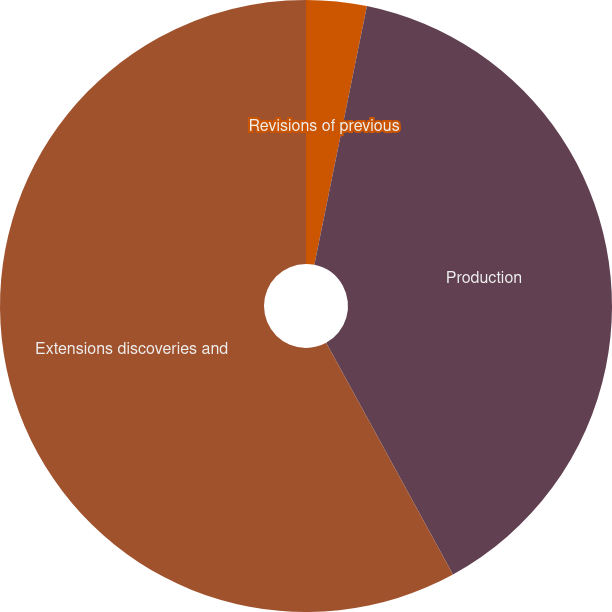Convert chart to OTSL. <chart><loc_0><loc_0><loc_500><loc_500><pie_chart><fcel>Revisions of previous<fcel>Production<fcel>Extensions discoveries and<nl><fcel>3.19%<fcel>38.84%<fcel>57.98%<nl></chart> 